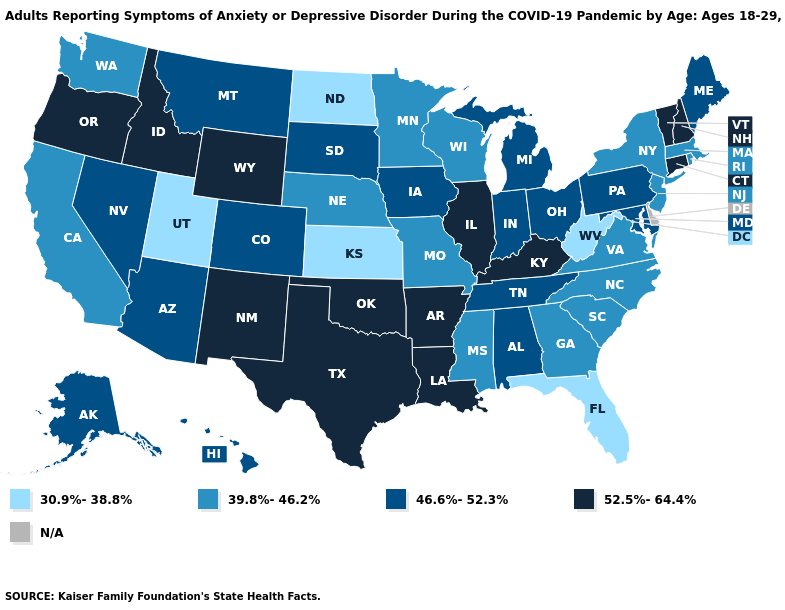How many symbols are there in the legend?
Write a very short answer. 5. Does Kentucky have the highest value in the USA?
Write a very short answer. Yes. Is the legend a continuous bar?
Concise answer only. No. Name the states that have a value in the range 52.5%-64.4%?
Short answer required. Arkansas, Connecticut, Idaho, Illinois, Kentucky, Louisiana, New Hampshire, New Mexico, Oklahoma, Oregon, Texas, Vermont, Wyoming. Which states have the highest value in the USA?
Keep it brief. Arkansas, Connecticut, Idaho, Illinois, Kentucky, Louisiana, New Hampshire, New Mexico, Oklahoma, Oregon, Texas, Vermont, Wyoming. Name the states that have a value in the range 46.6%-52.3%?
Keep it brief. Alabama, Alaska, Arizona, Colorado, Hawaii, Indiana, Iowa, Maine, Maryland, Michigan, Montana, Nevada, Ohio, Pennsylvania, South Dakota, Tennessee. What is the highest value in states that border North Dakota?
Short answer required. 46.6%-52.3%. Name the states that have a value in the range 46.6%-52.3%?
Write a very short answer. Alabama, Alaska, Arizona, Colorado, Hawaii, Indiana, Iowa, Maine, Maryland, Michigan, Montana, Nevada, Ohio, Pennsylvania, South Dakota, Tennessee. What is the lowest value in the USA?
Give a very brief answer. 30.9%-38.8%. Name the states that have a value in the range 46.6%-52.3%?
Answer briefly. Alabama, Alaska, Arizona, Colorado, Hawaii, Indiana, Iowa, Maine, Maryland, Michigan, Montana, Nevada, Ohio, Pennsylvania, South Dakota, Tennessee. How many symbols are there in the legend?
Keep it brief. 5. What is the lowest value in the MidWest?
Give a very brief answer. 30.9%-38.8%. Name the states that have a value in the range N/A?
Quick response, please. Delaware. What is the lowest value in states that border North Dakota?
Quick response, please. 39.8%-46.2%. What is the value of Oregon?
Quick response, please. 52.5%-64.4%. 